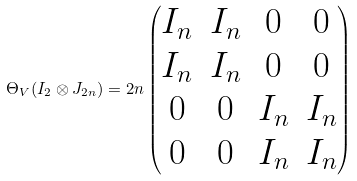<formula> <loc_0><loc_0><loc_500><loc_500>\Theta _ { V } ( I _ { 2 } \otimes J _ { 2 n } ) = 2 n \begin{pmatrix} I _ { n } & I _ { n } & 0 & 0 \\ I _ { n } & I _ { n } & 0 & 0 \\ 0 & 0 & I _ { n } & I _ { n } \\ 0 & 0 & I _ { n } & I _ { n } \\ \end{pmatrix}</formula> 